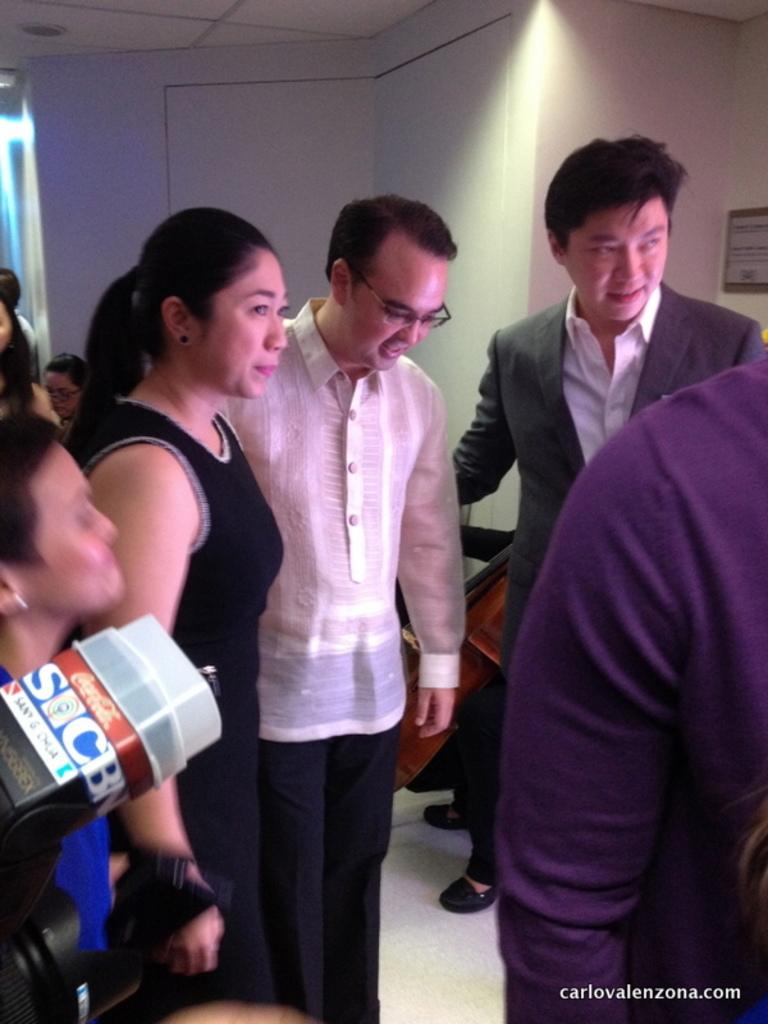What is happening in the image? There are people standing in the image. What can be seen on the left side of the image? There is a camera on the left side of the image. What is visible in the background of the image? There is a white wall in the background of the image. What is present at the bottom of the image? There is a watermark at the bottom of the image. What type of soup is being served in the image? There is no soup present in the image. How do the people in the image plan to rest after their activity? The image does not show any information about the people's plans after their activity. 